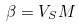Convert formula to latex. <formula><loc_0><loc_0><loc_500><loc_500>\beta = V _ { S } M</formula> 